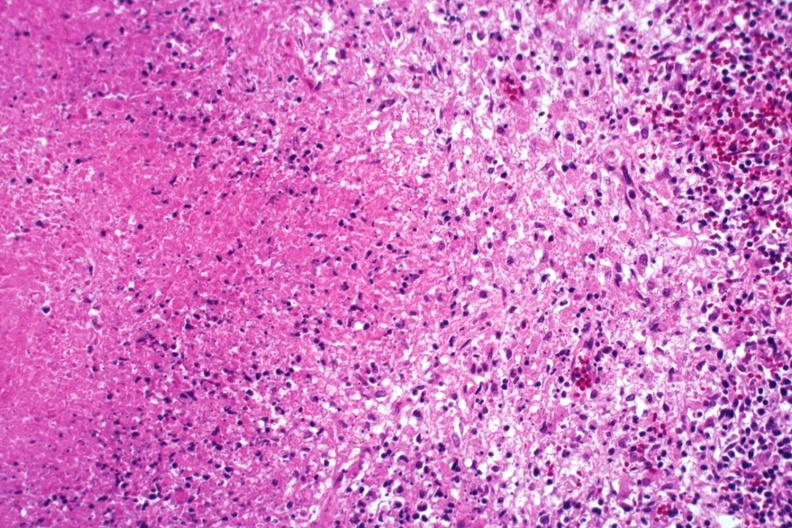s tuberculosis present?
Answer the question using a single word or phrase. Yes 